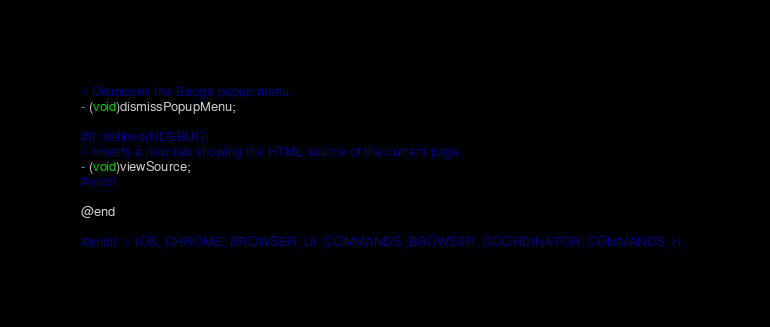Convert code to text. <code><loc_0><loc_0><loc_500><loc_500><_C_>
// Dismisses the Badge popup menu.
- (void)dismissPopupMenu;

#if !defined(NDEBUG)
// Inserts a new tab showing the HTML source of the current page.
- (void)viewSource;
#endif

@end

#endif  // IOS_CHROME_BROWSER_UI_COMMANDS_BROWSER_COORDINATOR_COMMANDS_H_
</code> 